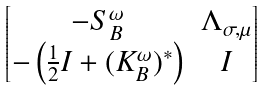<formula> <loc_0><loc_0><loc_500><loc_500>\begin{bmatrix} - S ^ { \omega } _ { B } & \Lambda _ { \sigma , \mu } \\ - \left ( \frac { 1 } { 2 } I + ( K ^ { \omega } _ { B } ) ^ { * } \right ) & I \end{bmatrix}</formula> 